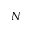Convert formula to latex. <formula><loc_0><loc_0><loc_500><loc_500>N</formula> 